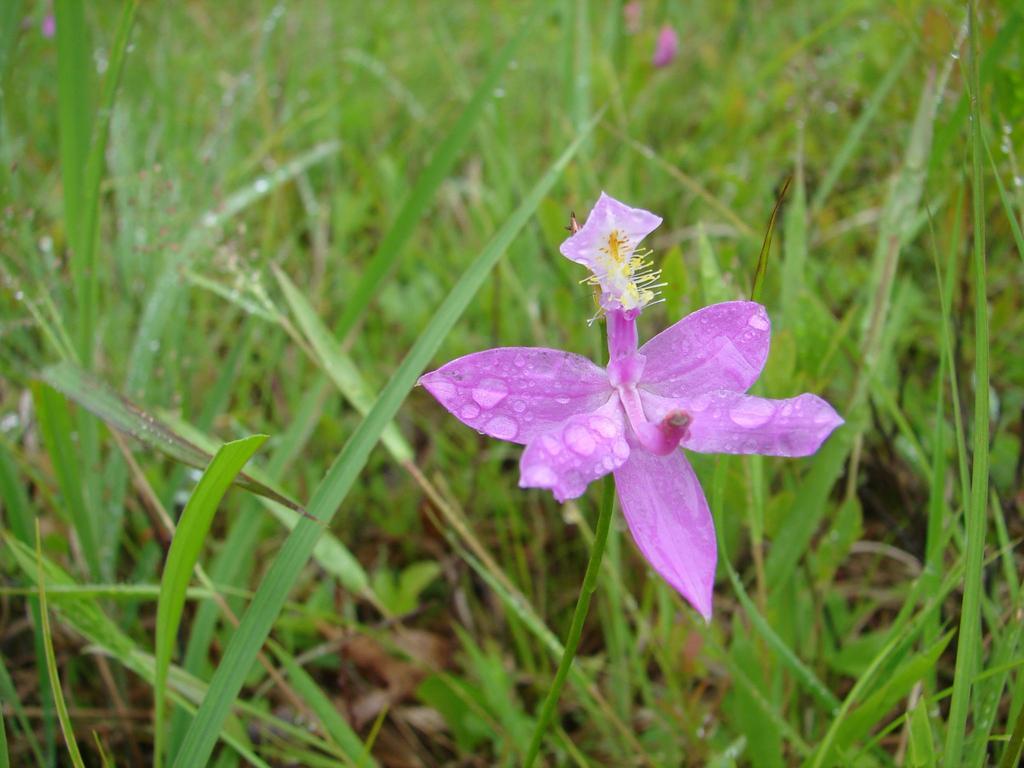Please provide a concise description of this image. In this picture, there is a flower towards the right. It is in purple in color. In the background there is grass. 